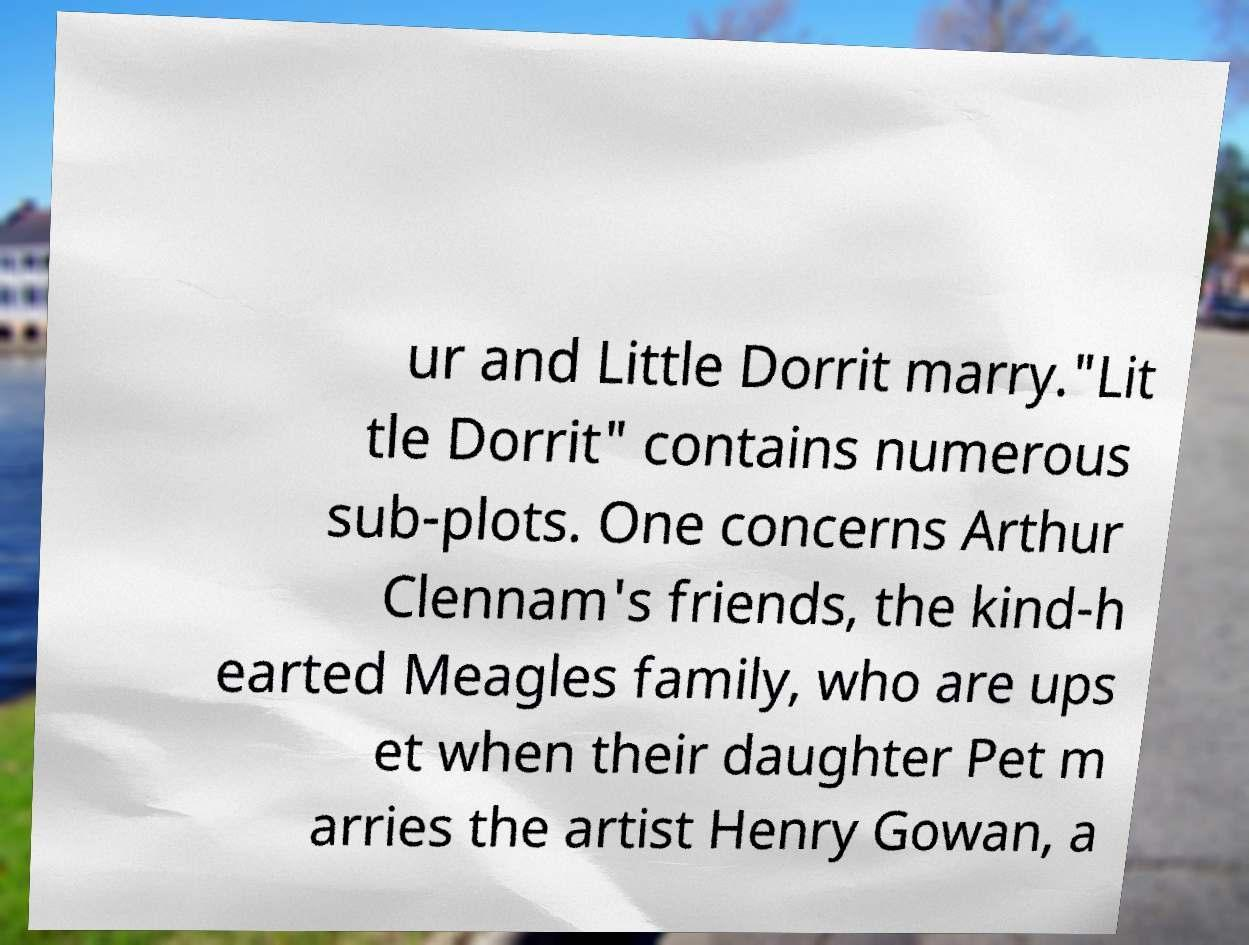Please read and relay the text visible in this image. What does it say? ur and Little Dorrit marry."Lit tle Dorrit" contains numerous sub-plots. One concerns Arthur Clennam's friends, the kind-h earted Meagles family, who are ups et when their daughter Pet m arries the artist Henry Gowan, a 